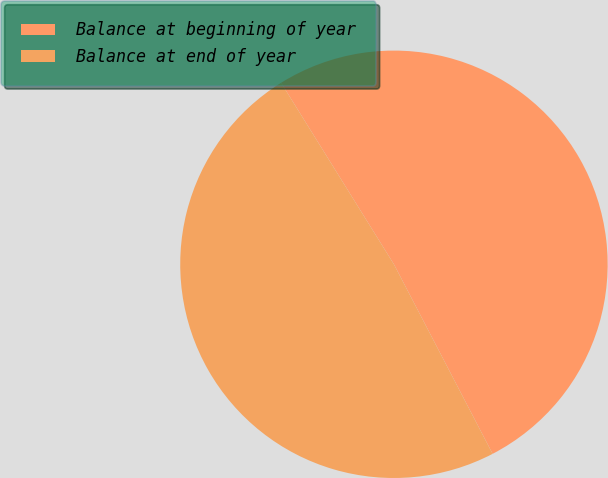Convert chart to OTSL. <chart><loc_0><loc_0><loc_500><loc_500><pie_chart><fcel>Balance at beginning of year<fcel>Balance at end of year<nl><fcel>51.21%<fcel>48.79%<nl></chart> 